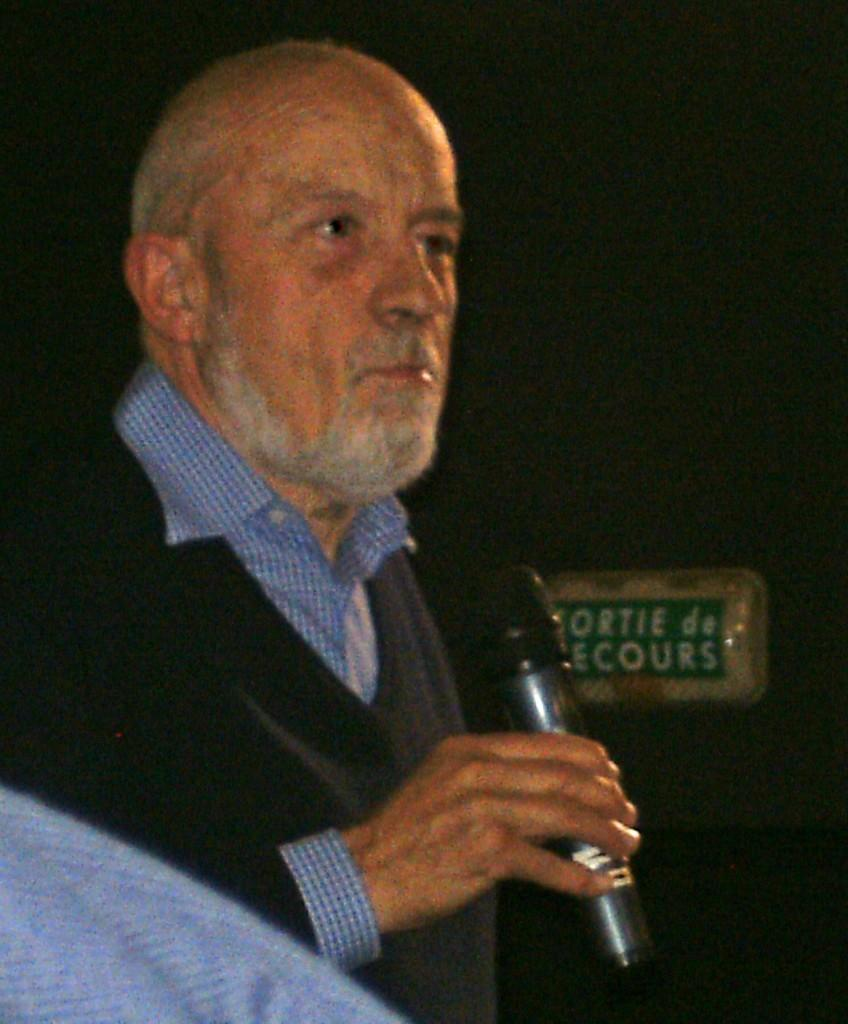What is the main subject of the image? The main subject of the subject of the image is a man. What is the man wearing in the image? The man is wearing a shirt in the image. What object is the man holding in his hand? The man is holding a microphone in his hand. What can be seen in the background of the image? There are words visible in the background of the image, and the background is dark. Reasoning: Let's step by step in order to produce the conversation. We start by identifying the main subject of the image, which is the man. Then, we describe the man's clothing and the object he is holding, which is a microphone. Next, we mention the background details, including the visible words and the dark color. Each question is designed to elicit a specific detail about the image that is known from the provided facts. Absurd Question/Answer: How many cattle are present in the image? There are no cattle visible in the image. What type of baseball equipment can be seen in the image? There is no baseball equipment present in the image. 